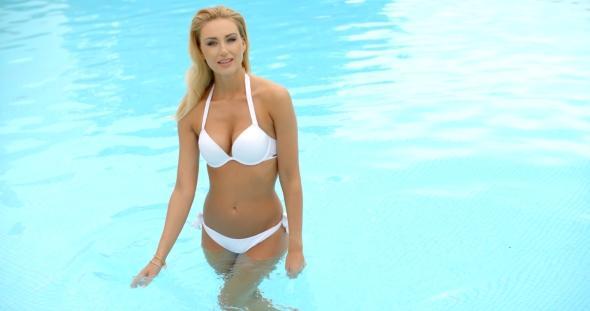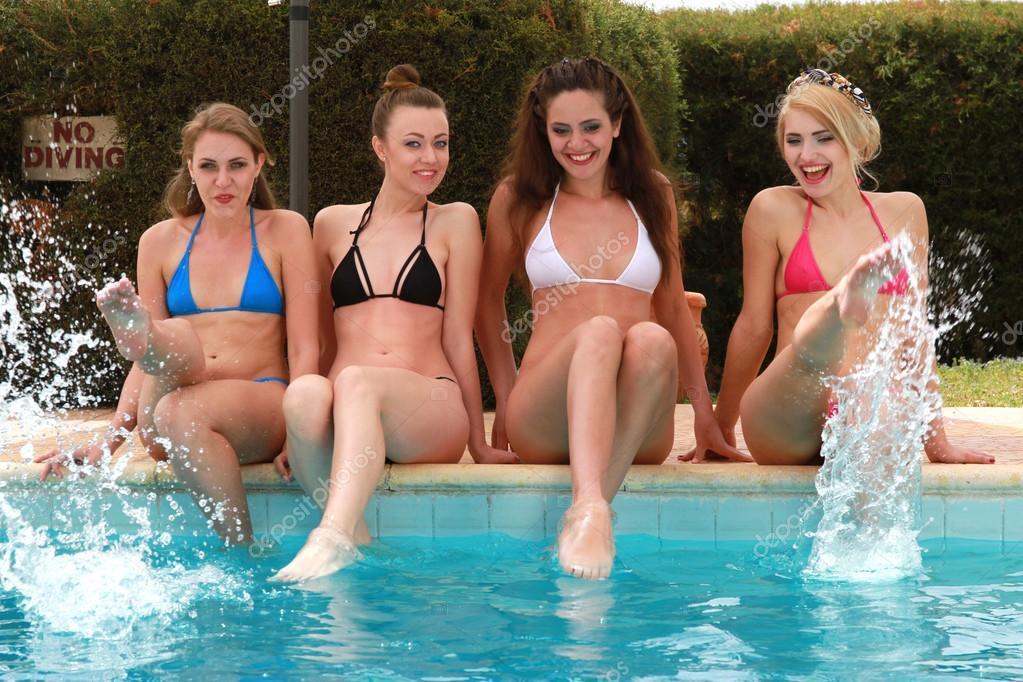The first image is the image on the left, the second image is the image on the right. For the images shown, is this caption "The left image contains exactly one person in the water." true? Answer yes or no. Yes. 